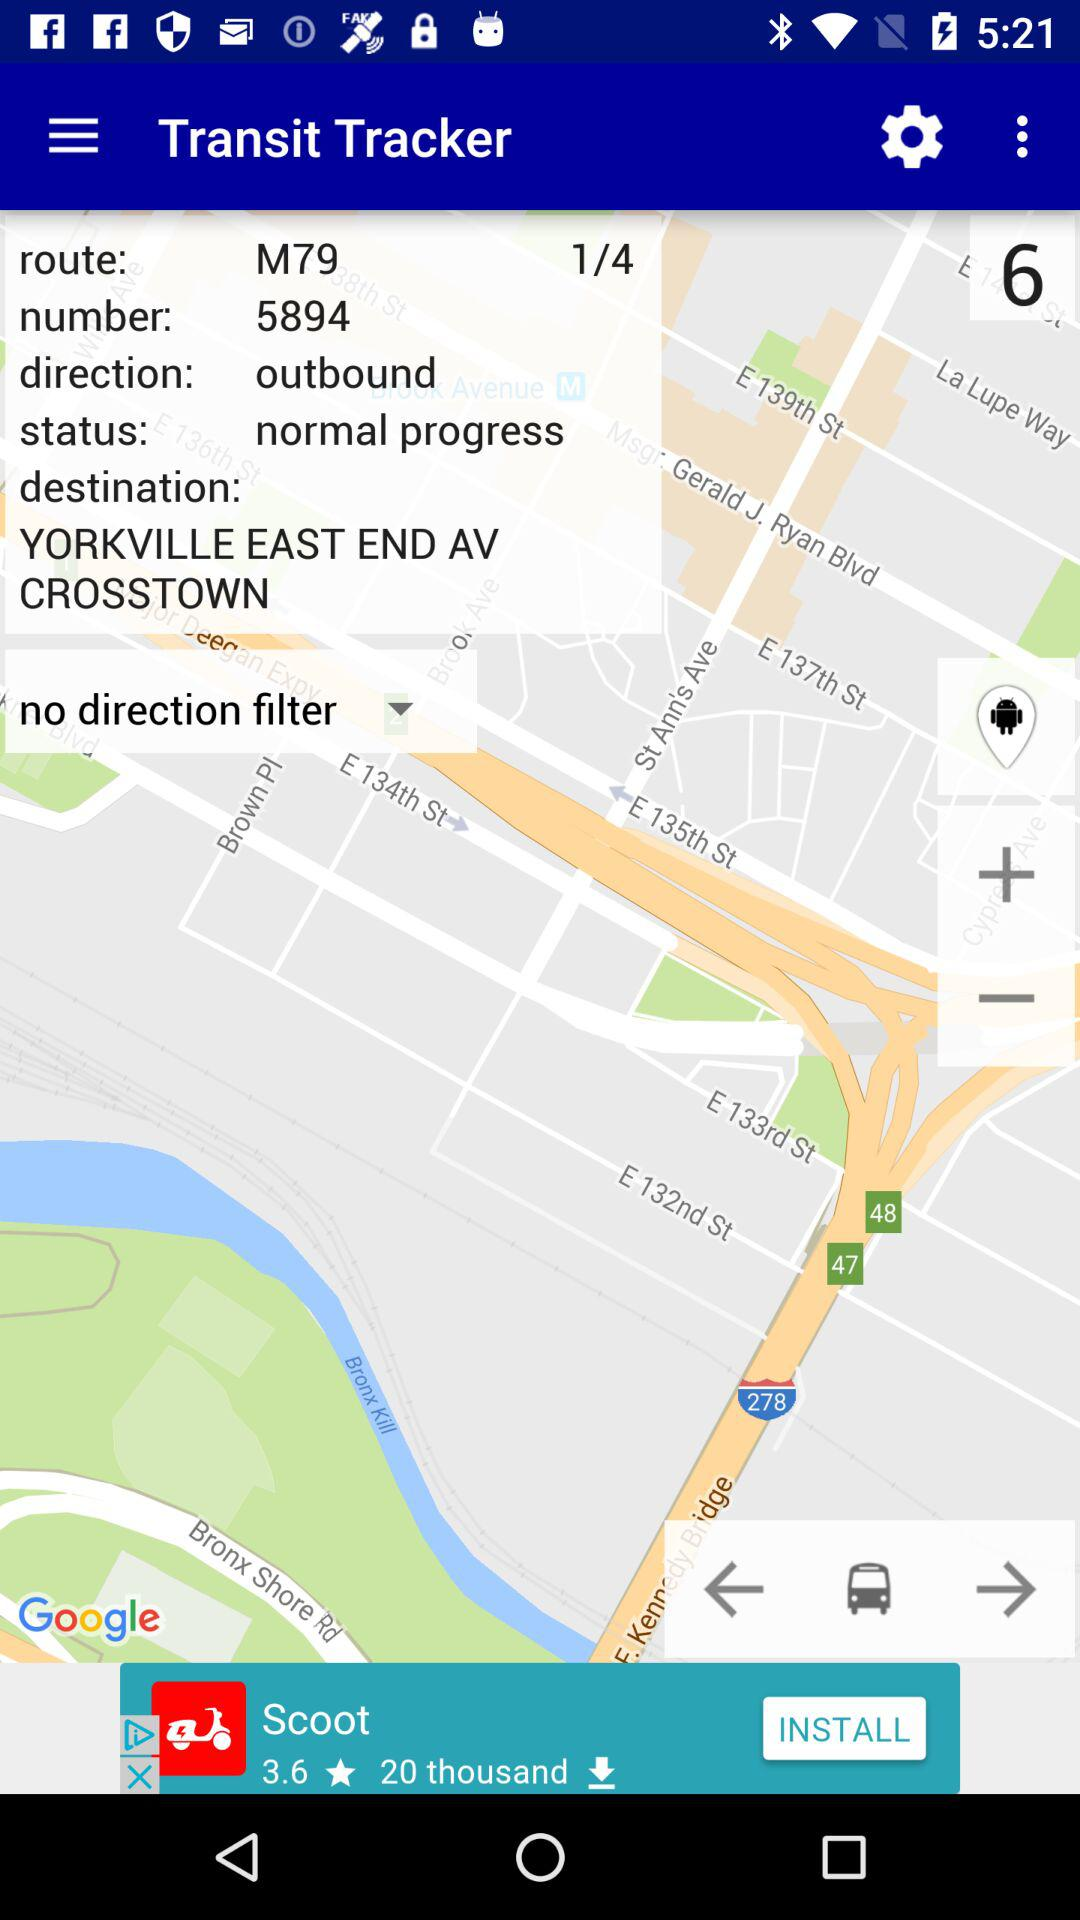What is the destination address? The destination address is Yorkville, East End Avenue, Crosstown. 